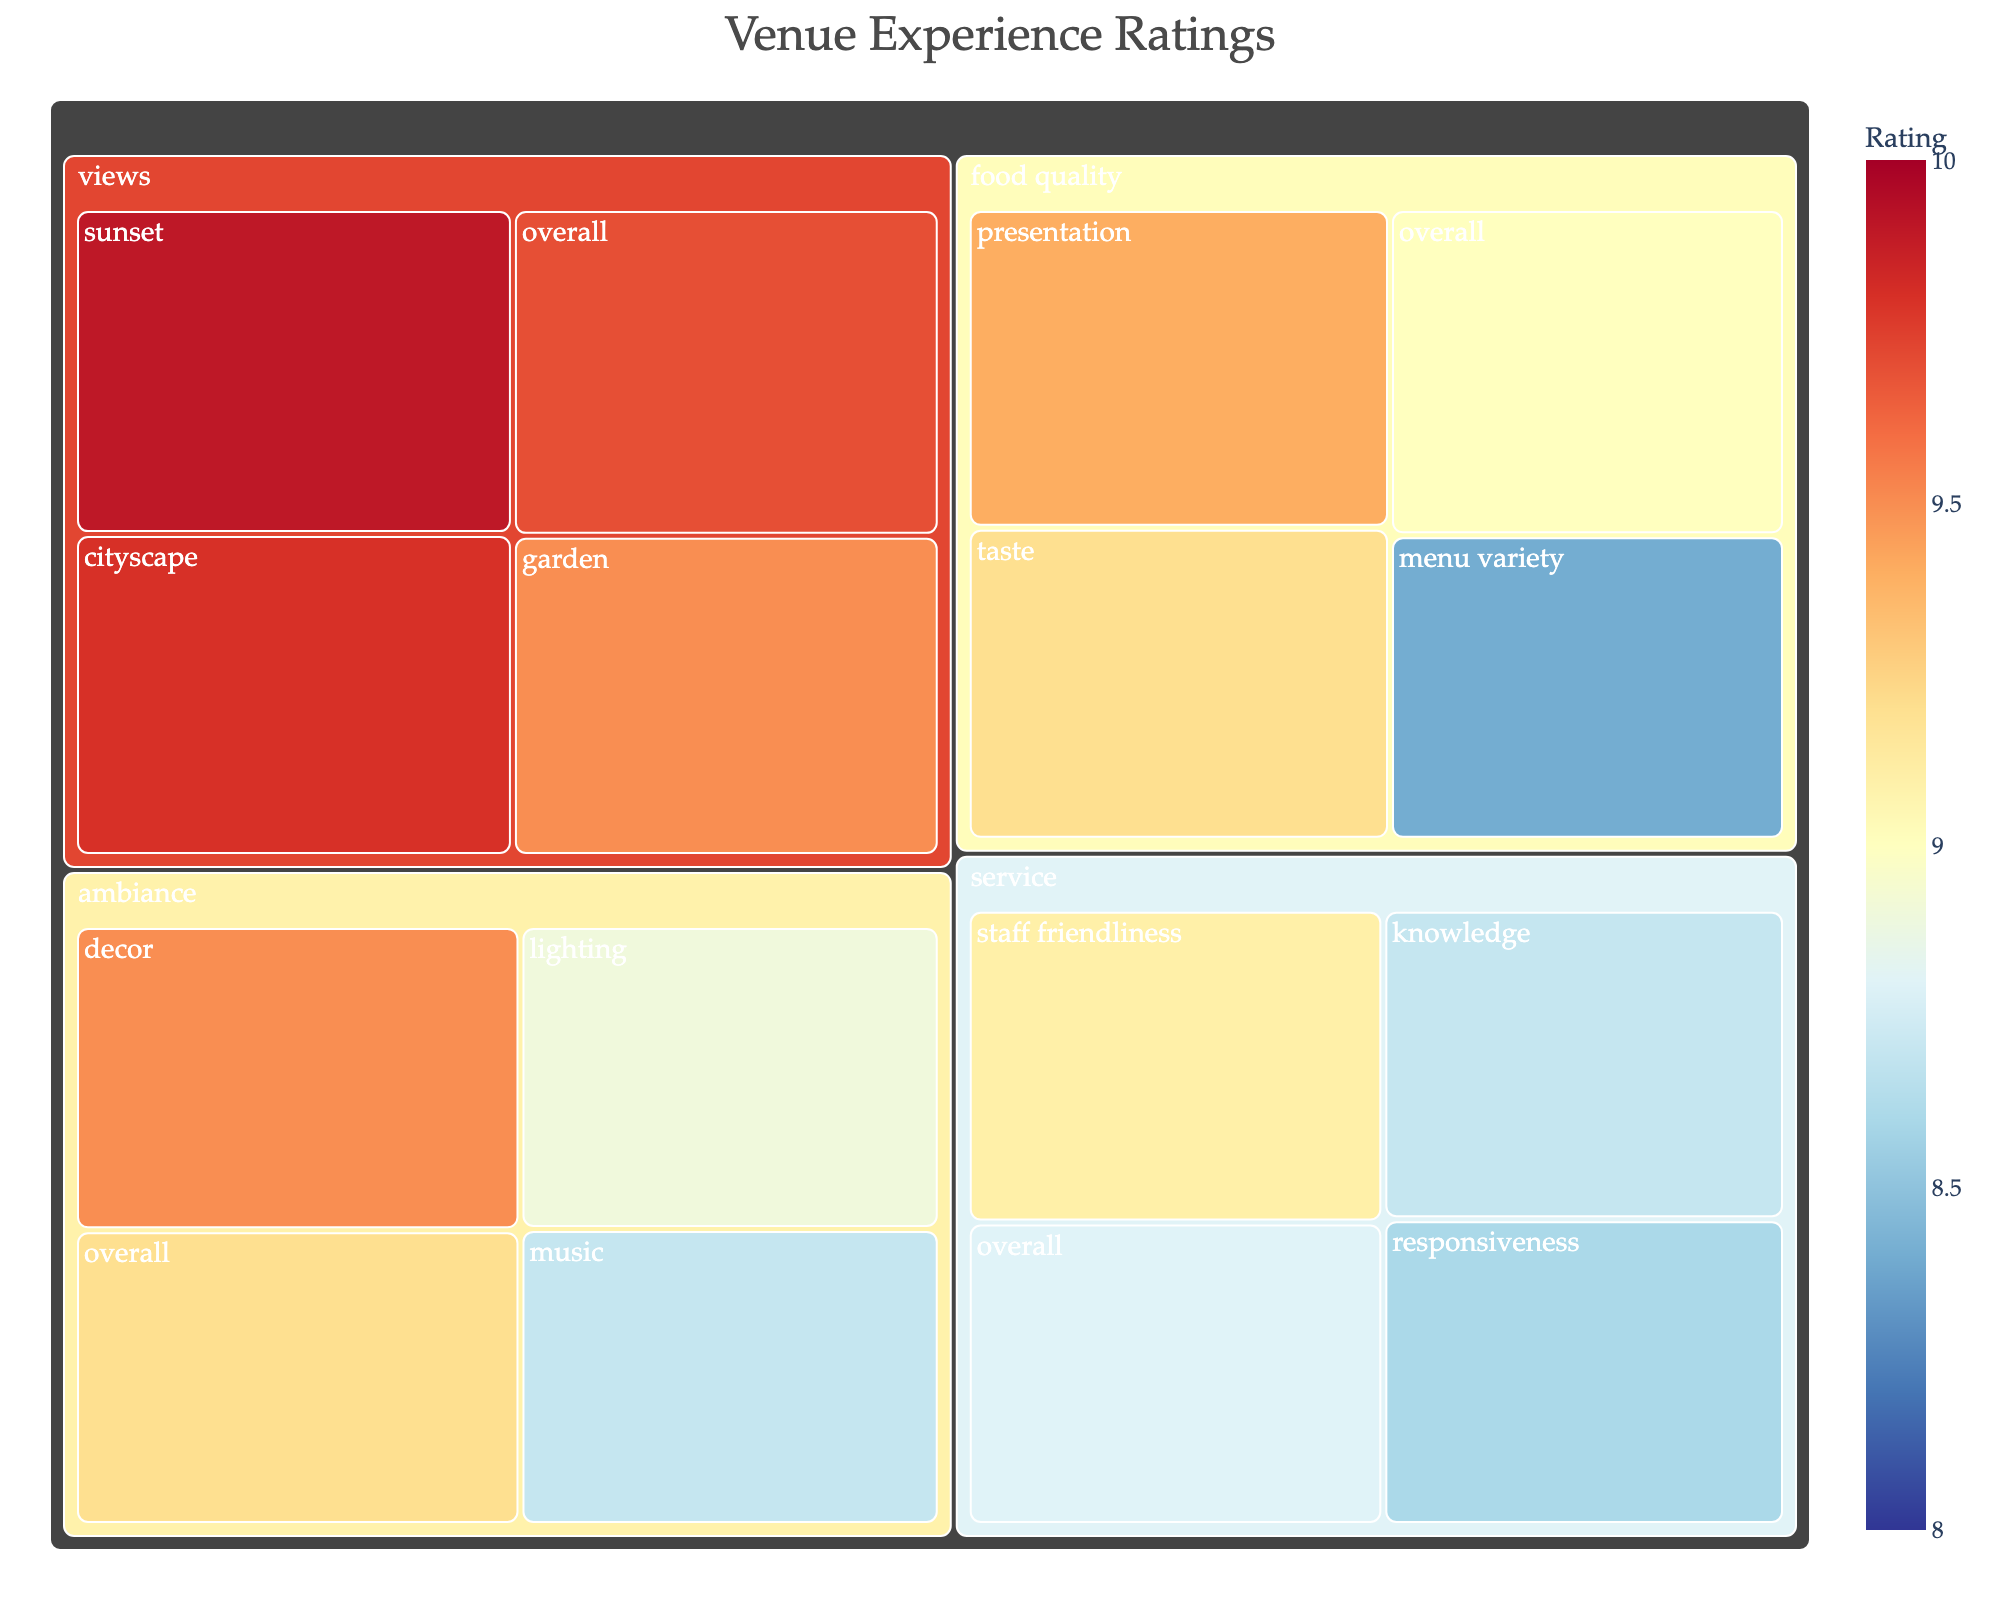Which aspect of the venue experience received the highest overall rating? The tree map shows that "views" received the highest overall rating of 9.7.
Answer: Views What is the individual category rating for "cityscape" under "views"? The rating can be directly observed under the "views" aspect in the treemap, which shows "cityscape" as having a rating of 9.8.
Answer: 9.8 How does the rating for "decor" under "ambiance" compare to the rating for "taste" under "food quality"? From the treemap, "decor" under "ambiance" has a rating of 9.5 while "taste" under "food quality" has a rating of 9.2. Comparatively, "decor" is higher by 0.3 points.
Answer: Decor rating is higher What is the average rating of all the categories under "food quality"? Add the individual ratings under "food quality" (9.0, 9.2, 9.4, 8.4) and divide by the number of categories (4). (9.0 + 9.2 + 9.4 + 8.4) / 4 = 36 / 4 = 9.0
Answer: 9.0 Between "service" and "ambiance," which aspect has better ratings based on the different sub-categories? Looking at the sub-category ratings, "ambiance" has higher ratings (8.9, 9.5, 8.7) compared to "service" (8.8, 9.1, 8.6, 8.7). On average, "ambiance" has slightly higher ratings.
Answer: Ambiance Which individual category has the lowest rating across the entire treemap? From the treemap, "menu variety" under "food quality" has the lowest rating of 8.4.
Answer: Menu variety What is the difference in rating between "staff friendliness" in service and "lighting" in ambiance? "Staff friendliness" in service has a rating of 9.1 and "lighting" in ambiance has a rating of 8.9. The difference is 9.1 - 8.9 = 0.2.
Answer: 0.2 What are the ratings for categories under "ambiance"? The categories under "ambiance" have the following ratings: overall 9.2, lighting 8.9, decor 9.5, music 8.7 as shown in the treemap.
Answer: 9.2, 8.9, 9.5, 8.7 What is the range of ratings given for the "views" aspect? The "views" aspect has ratings 9.7, 9.8, 9.9, and 9.5. The range is calculated as the difference between the highest and lowest rating, 9.9 - 9.5 = 0.4.
Answer: 0.4 